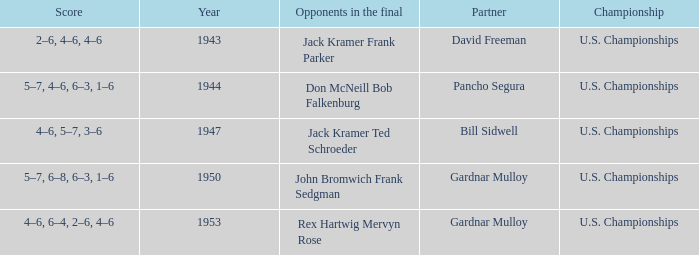Which Championship has a Score of 2–6, 4–6, 4–6? U.S. Championships. 